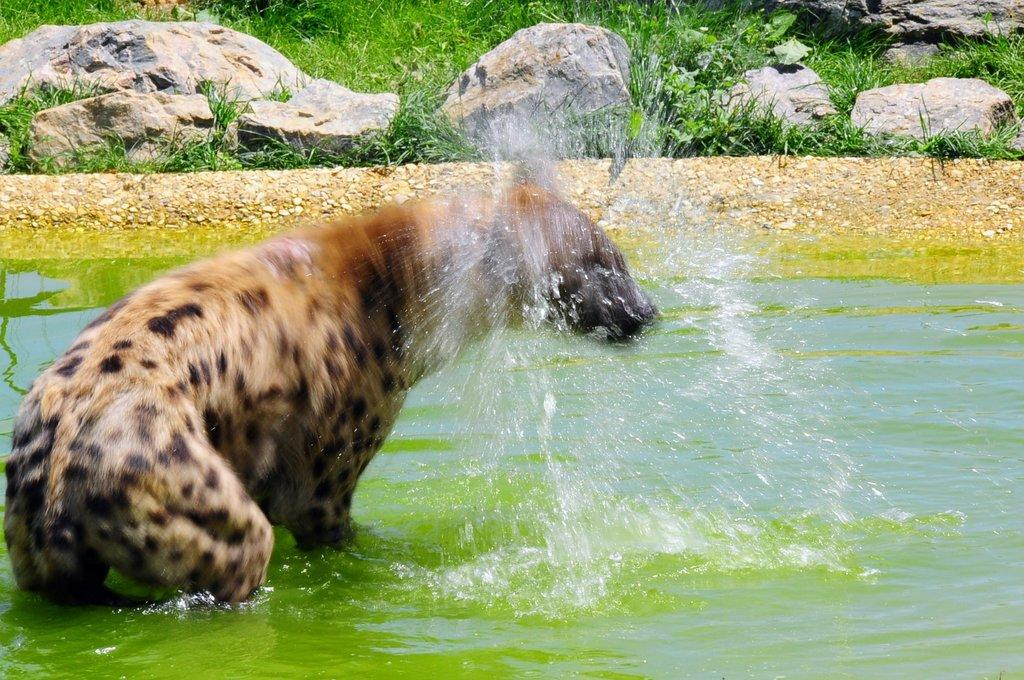Where was the picture taken? The picture was clicked outside the city. What can be seen in the image besides the landscape? A: There is a water body in the image, and an animal is present in the water body. What type of vegetation is visible in the background? There is green grass visible in the background. What other elements can be seen in the background? Rocks are present in the background. Can you hear the squirrel laughing in the image? There is no squirrel or laughter present in the image; it only features a water body, an animal, green grass, and rocks in the background. 